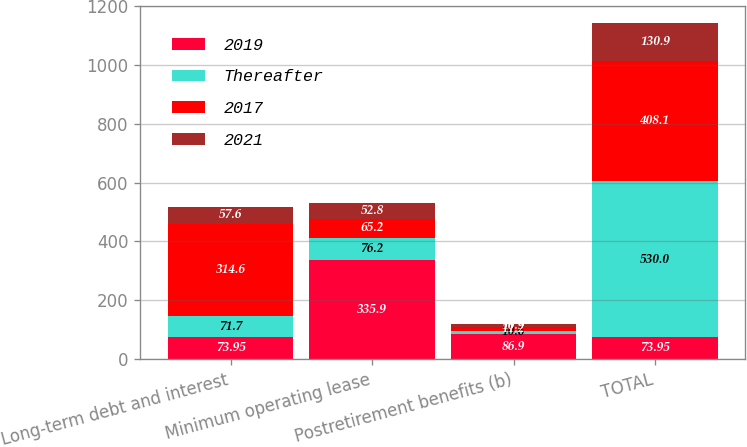Convert chart. <chart><loc_0><loc_0><loc_500><loc_500><stacked_bar_chart><ecel><fcel>Long-term debt and interest<fcel>Minimum operating lease<fcel>Postretirement benefits (b)<fcel>TOTAL<nl><fcel>2019<fcel>73.95<fcel>335.9<fcel>86.9<fcel>73.95<nl><fcel>Thereafter<fcel>71.7<fcel>76.2<fcel>10.6<fcel>530<nl><fcel>2017<fcel>314.6<fcel>65.2<fcel>11.2<fcel>408.1<nl><fcel>2021<fcel>57.6<fcel>52.8<fcel>10.9<fcel>130.9<nl></chart> 